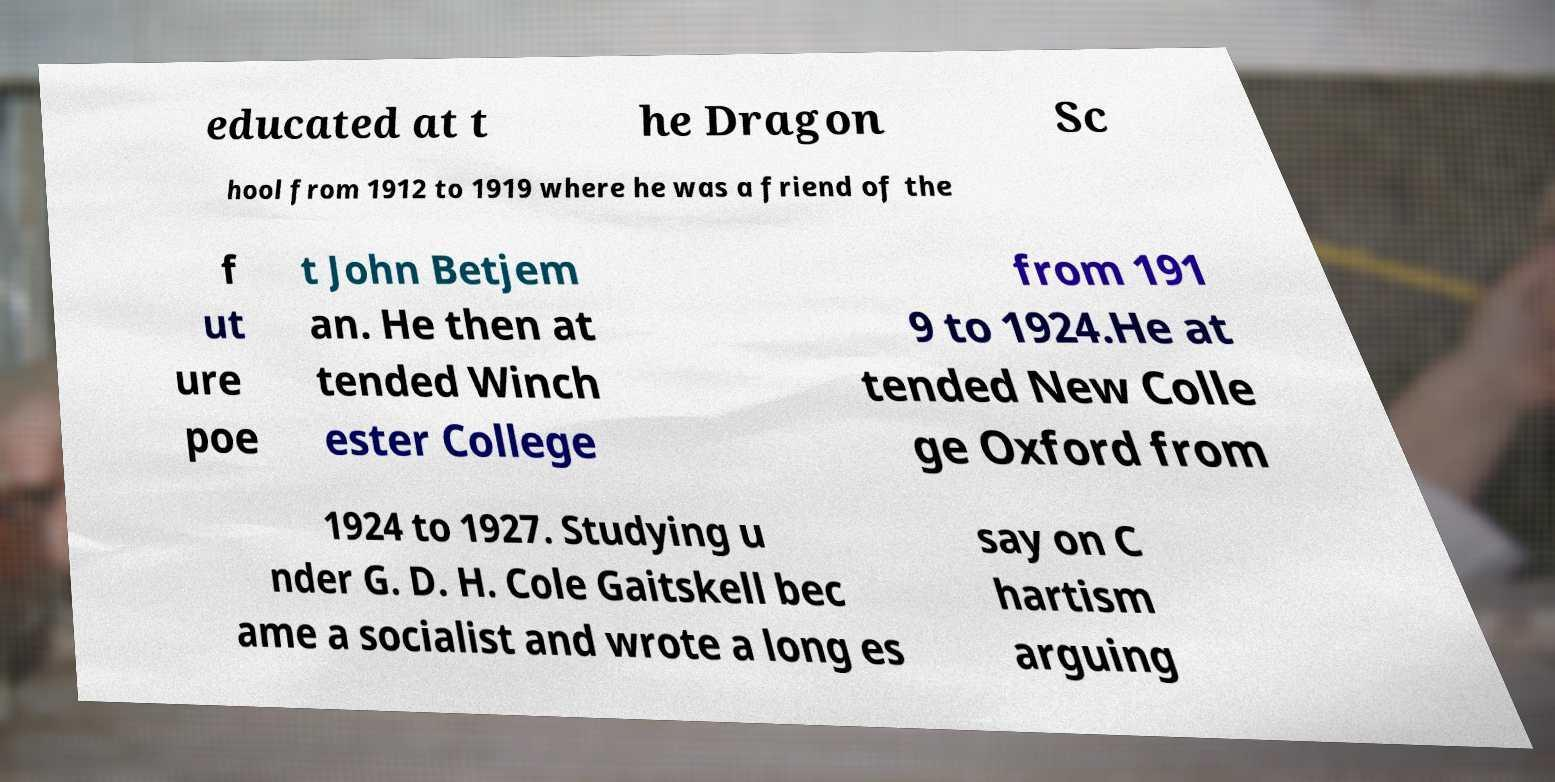Please read and relay the text visible in this image. What does it say? educated at t he Dragon Sc hool from 1912 to 1919 where he was a friend of the f ut ure poe t John Betjem an. He then at tended Winch ester College from 191 9 to 1924.He at tended New Colle ge Oxford from 1924 to 1927. Studying u nder G. D. H. Cole Gaitskell bec ame a socialist and wrote a long es say on C hartism arguing 